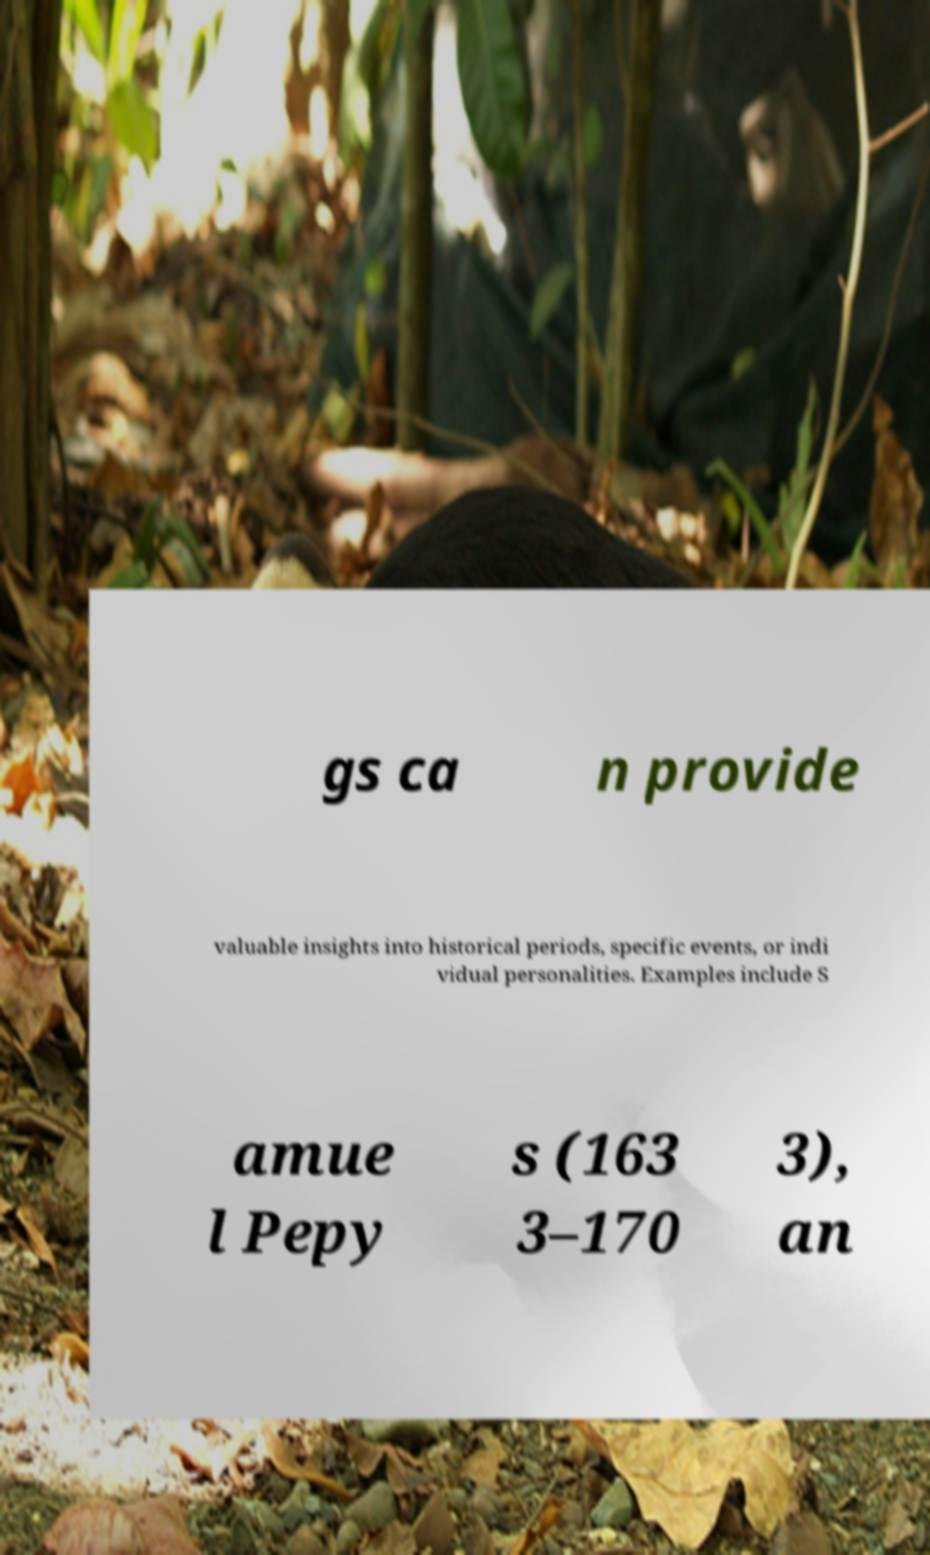Can you accurately transcribe the text from the provided image for me? gs ca n provide valuable insights into historical periods, specific events, or indi vidual personalities. Examples include S amue l Pepy s (163 3–170 3), an 